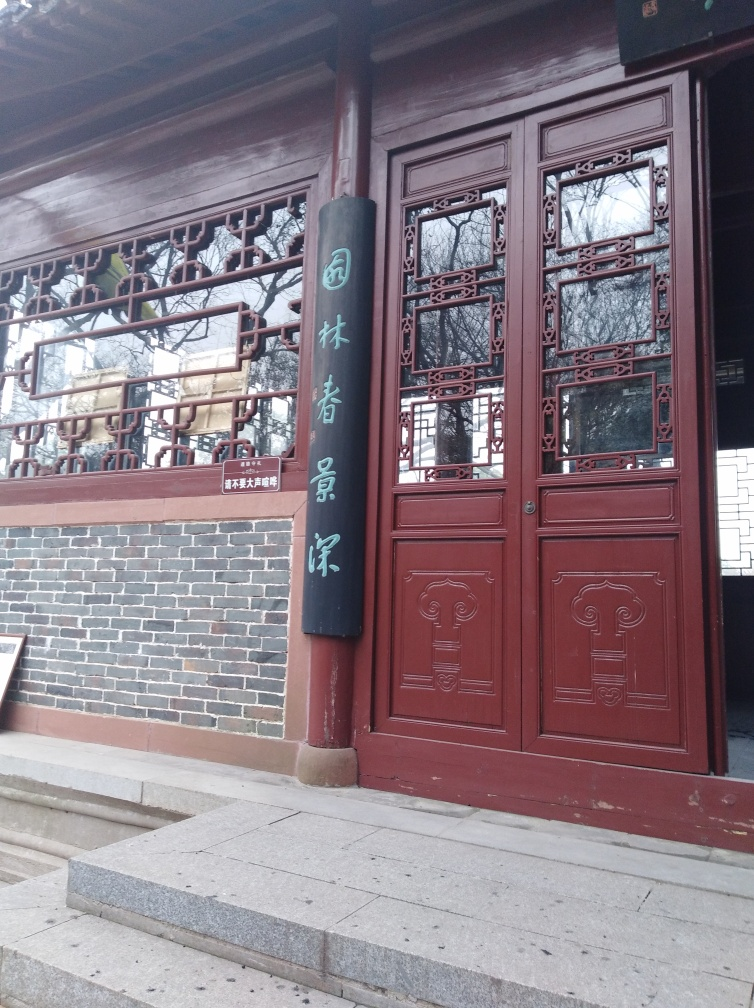Can you tell me more about the architectural style? Certainly, the architectural style shown is typical of historic East Asian design, with intricate woodwork evident in the window frames, which suggests a focus on craftsmanship and detail often found in traditional Chinese architecture. 